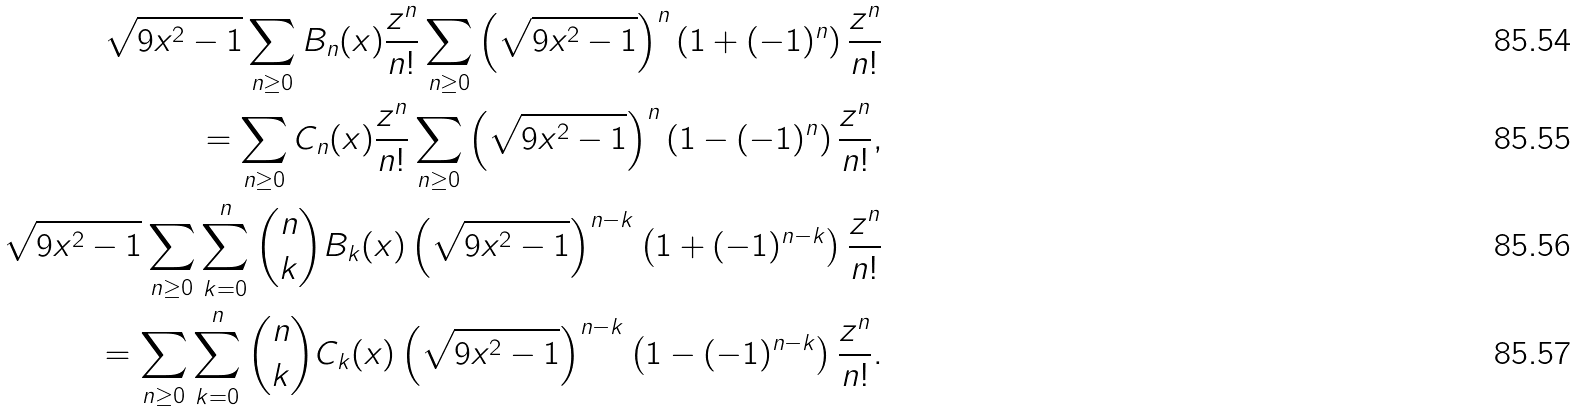<formula> <loc_0><loc_0><loc_500><loc_500>\sqrt { 9 x ^ { 2 } - 1 } \sum _ { n \geq 0 } B _ { n } ( x ) \frac { z ^ { n } } { n ! } \sum _ { n \geq 0 } \left ( \sqrt { 9 x ^ { 2 } - 1 } \right ) ^ { n } \left ( 1 + ( - 1 ) ^ { n } \right ) \frac { z ^ { n } } { n ! } \\ = \sum _ { n \geq 0 } C _ { n } ( x ) \frac { z ^ { n } } { n ! } \sum _ { n \geq 0 } \left ( \sqrt { 9 x ^ { 2 } - 1 } \right ) ^ { n } \left ( 1 - ( - 1 ) ^ { n } \right ) \frac { z ^ { n } } { n ! } , \\ \sqrt { 9 x ^ { 2 } - 1 } \sum _ { n \geq 0 } \sum _ { k = 0 } ^ { n } { n \choose k } B _ { k } ( x ) \left ( \sqrt { 9 x ^ { 2 } - 1 } \right ) ^ { n - k } \left ( 1 + ( - 1 ) ^ { n - k } \right ) \frac { z ^ { n } } { n ! } \\ = \sum _ { n \geq 0 } \sum _ { k = 0 } ^ { n } { n \choose k } C _ { k } ( x ) \left ( \sqrt { 9 x ^ { 2 } - 1 } \right ) ^ { n - k } \left ( 1 - ( - 1 ) ^ { n - k } \right ) \frac { z ^ { n } } { n ! } .</formula> 